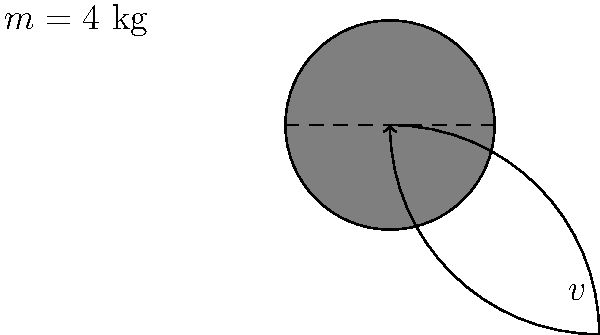Champ, remember those days in the ring? Now, let's apply that to a speed bag. You've just given it a solid punch, and it's oscillating with a maximum speed of 5 m/s. If the bag weighs 4 kg, what's its maximum kinetic energy during the oscillation? Don't pull any punches with your calculations! Alright, let's break this down step-by-step, just like we used to analyze our opponents:

1) First, recall the formula for kinetic energy:
   $$ KE = \frac{1}{2}mv^2 $$
   where $m$ is the mass and $v$ is the velocity.

2) We're given:
   - Mass of the speed bag, $m = 4$ kg
   - Maximum speed, $v = 5$ m/s

3) Now, let's plug these values into our equation:
   $$ KE = \frac{1}{2} \times 4 \text{ kg} \times (5 \text{ m/s})^2 $$

4) Let's calculate:
   $$ KE = \frac{1}{2} \times 4 \times 25 = 2 \times 25 = 50 \text{ J} $$

5) Therefore, the maximum kinetic energy of the speed bag during its oscillation is 50 Joules.

Remember, champ, in physics as in boxing, it's all about the energy you put in!
Answer: 50 J 